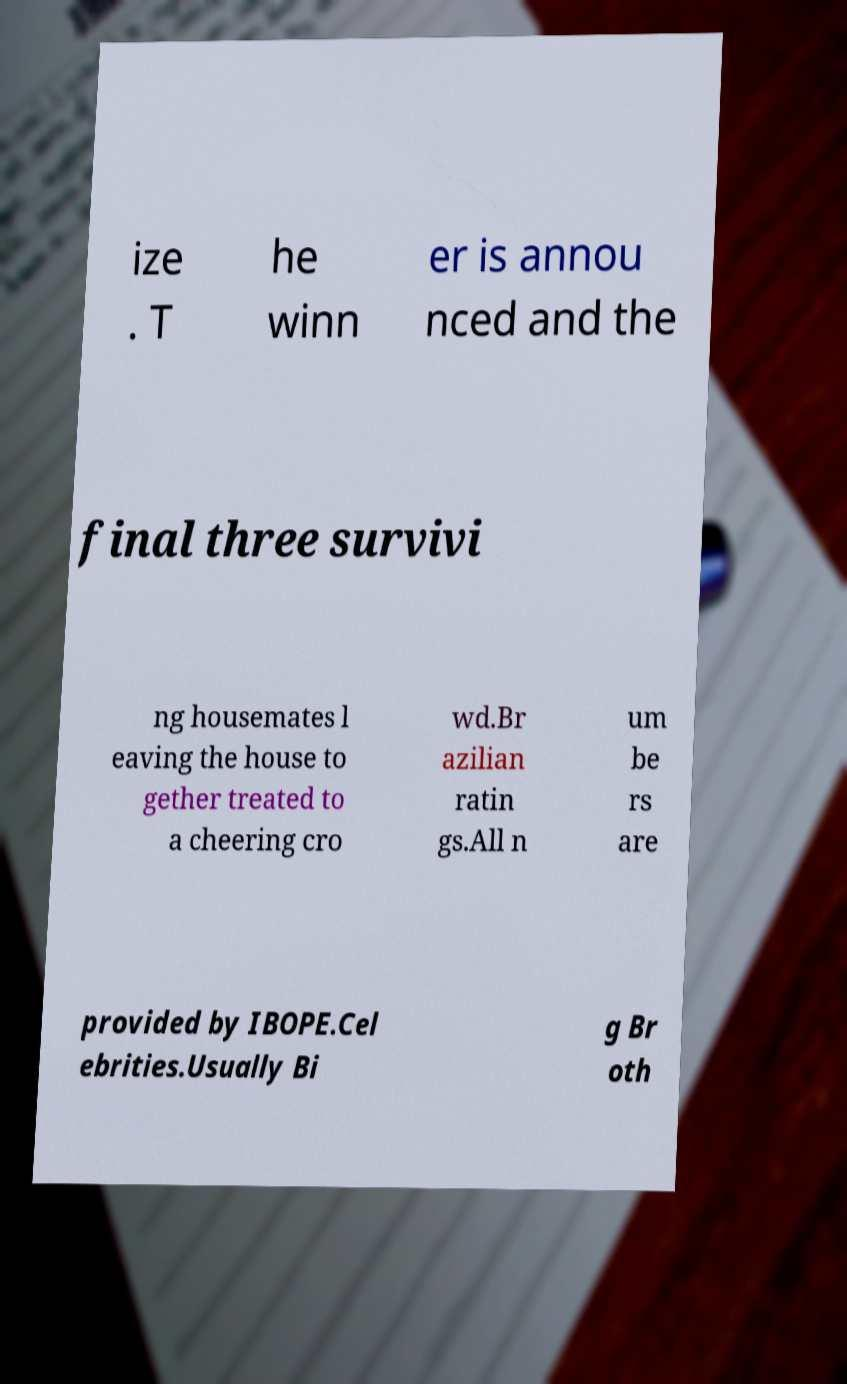Can you accurately transcribe the text from the provided image for me? ize . T he winn er is annou nced and the final three survivi ng housemates l eaving the house to gether treated to a cheering cro wd.Br azilian ratin gs.All n um be rs are provided by IBOPE.Cel ebrities.Usually Bi g Br oth 